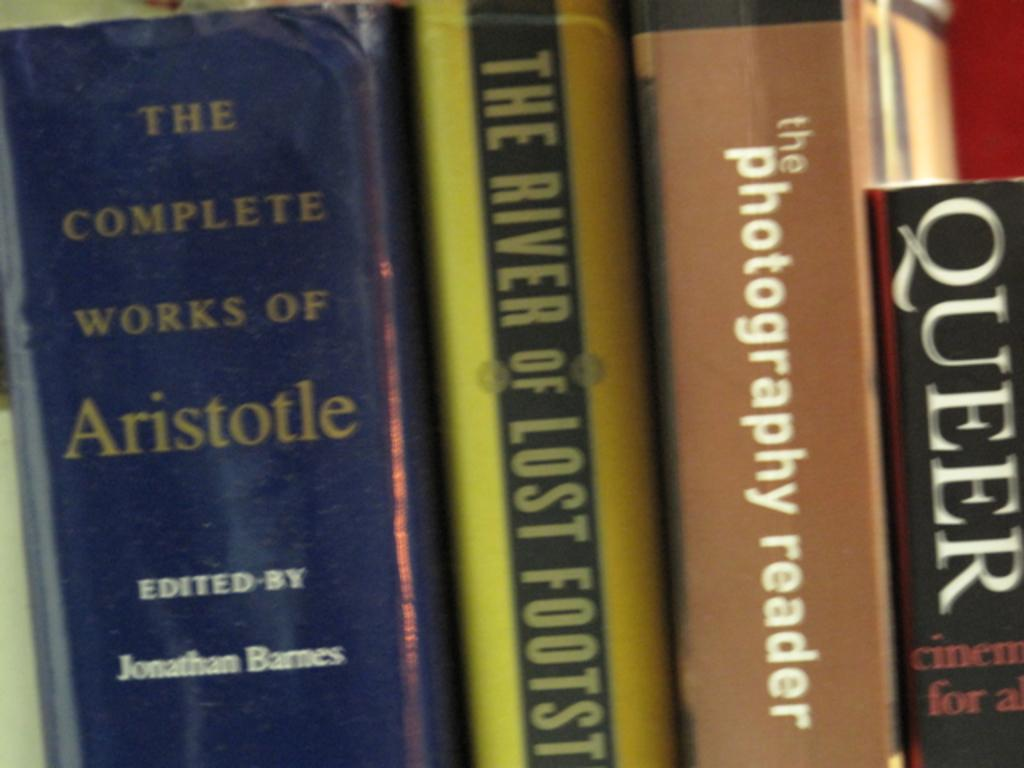Provide a one-sentence caption for the provided image. A various work of arts, books from Queer to Aristotle. 